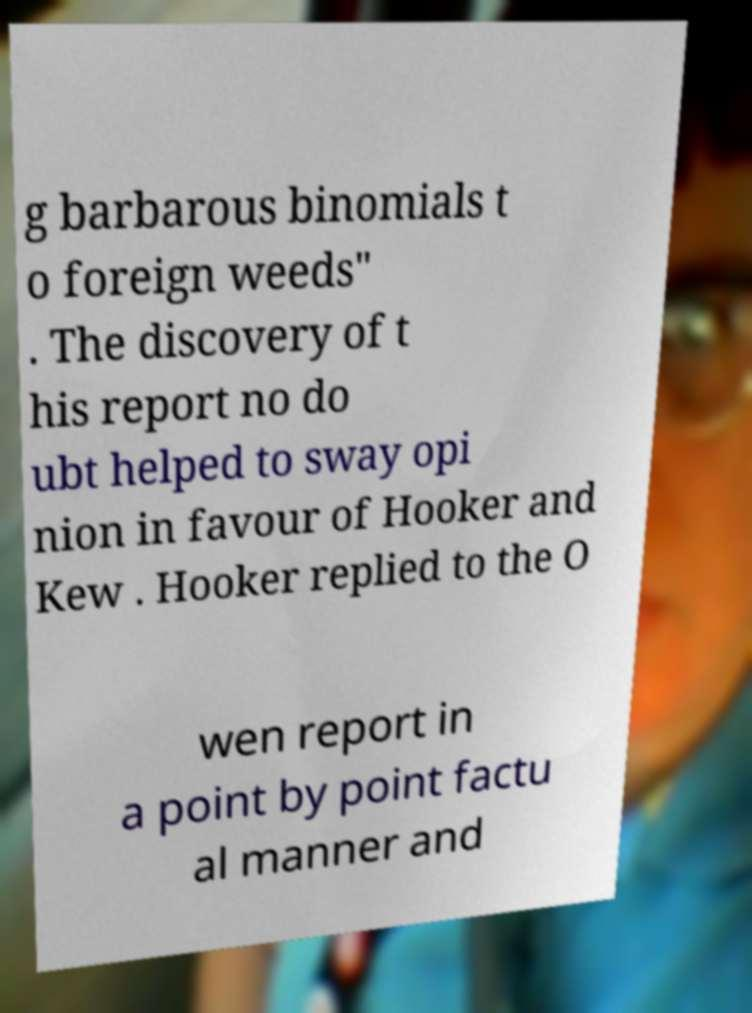What messages or text are displayed in this image? I need them in a readable, typed format. g barbarous binomials t o foreign weeds" . The discovery of t his report no do ubt helped to sway opi nion in favour of Hooker and Kew . Hooker replied to the O wen report in a point by point factu al manner and 